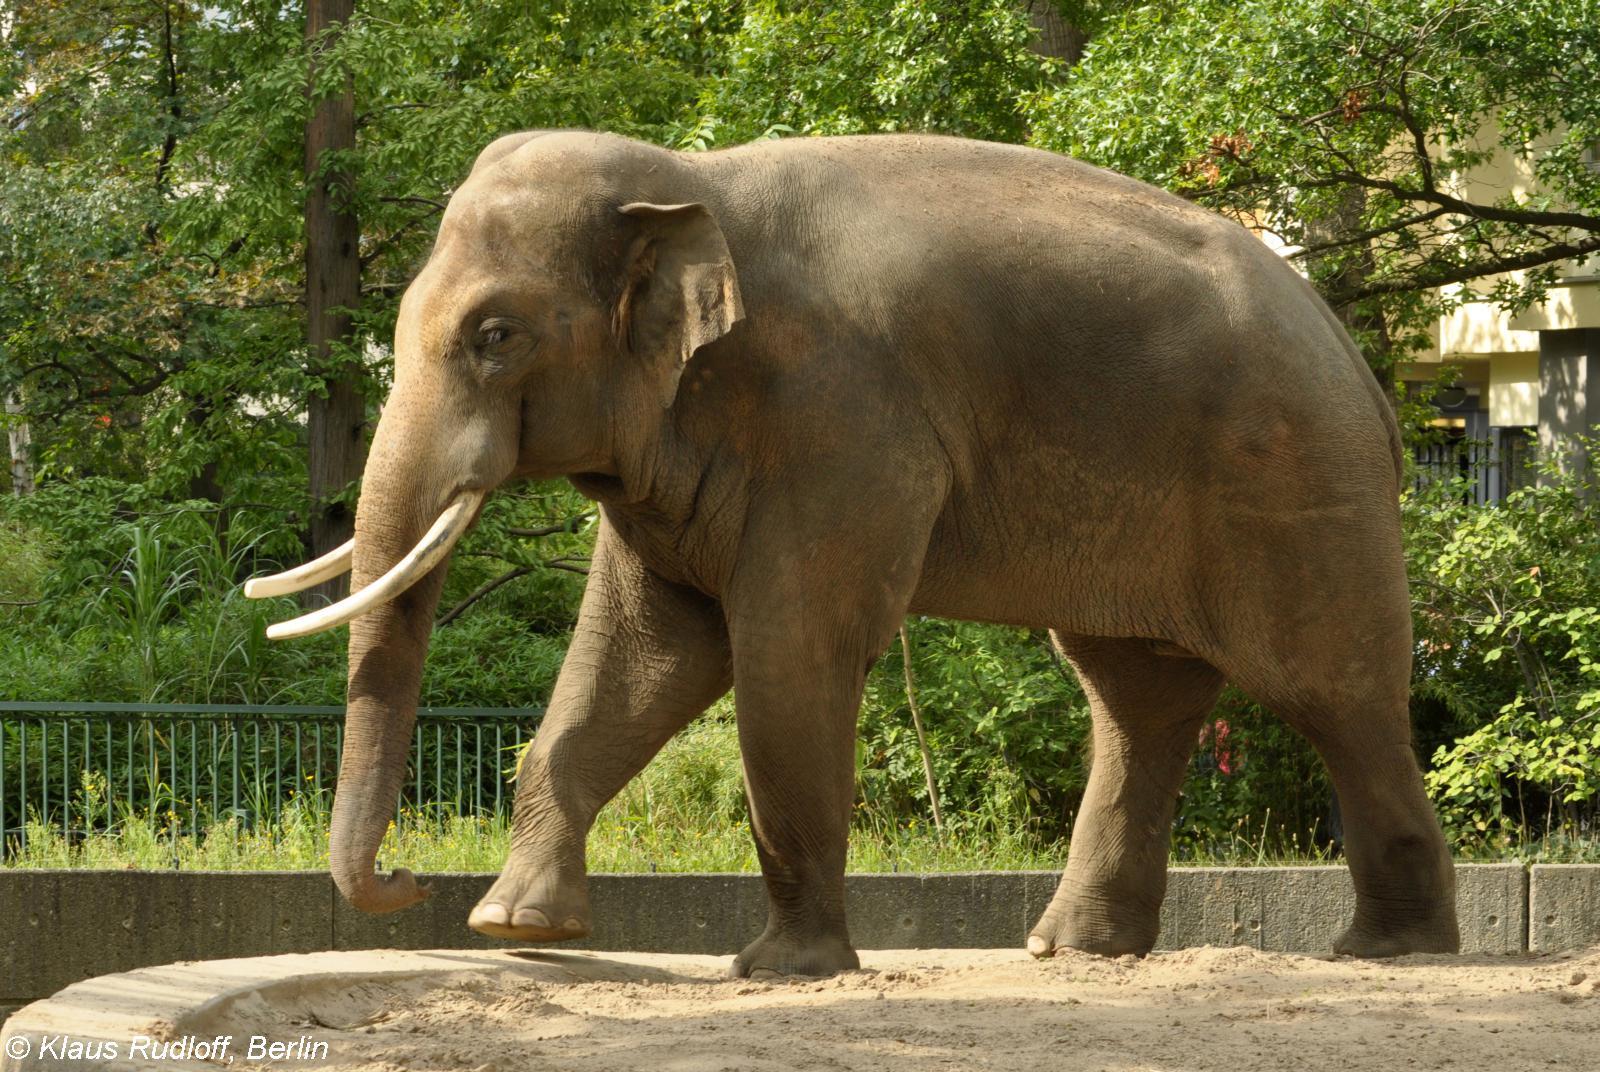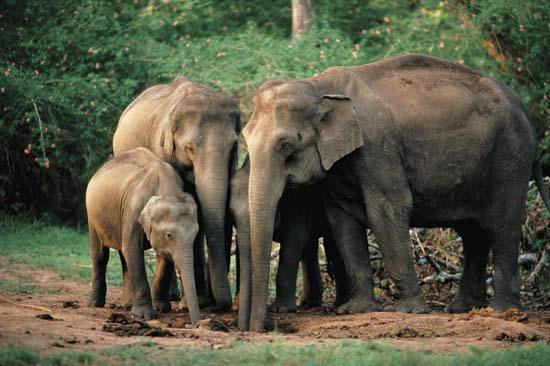The first image is the image on the left, the second image is the image on the right. Evaluate the accuracy of this statement regarding the images: "At least one of the images shows people interacting with an elephant.". Is it true? Answer yes or no. No. The first image is the image on the left, the second image is the image on the right. For the images displayed, is the sentence "At least one image shows people near an elephant with chained feet." factually correct? Answer yes or no. No. 